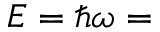<formula> <loc_0><loc_0><loc_500><loc_500>E = \hbar { \omega } =</formula> 